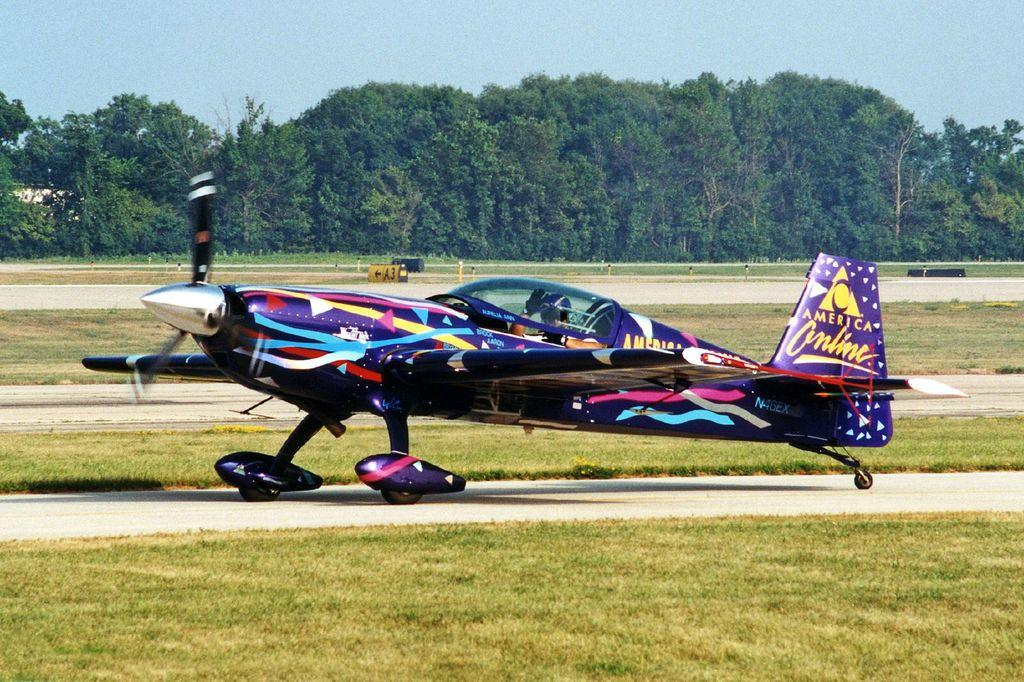<image>
Create a compact narrative representing the image presented. A small plane painted in a variety of colors has the America Online logo on the tail. 